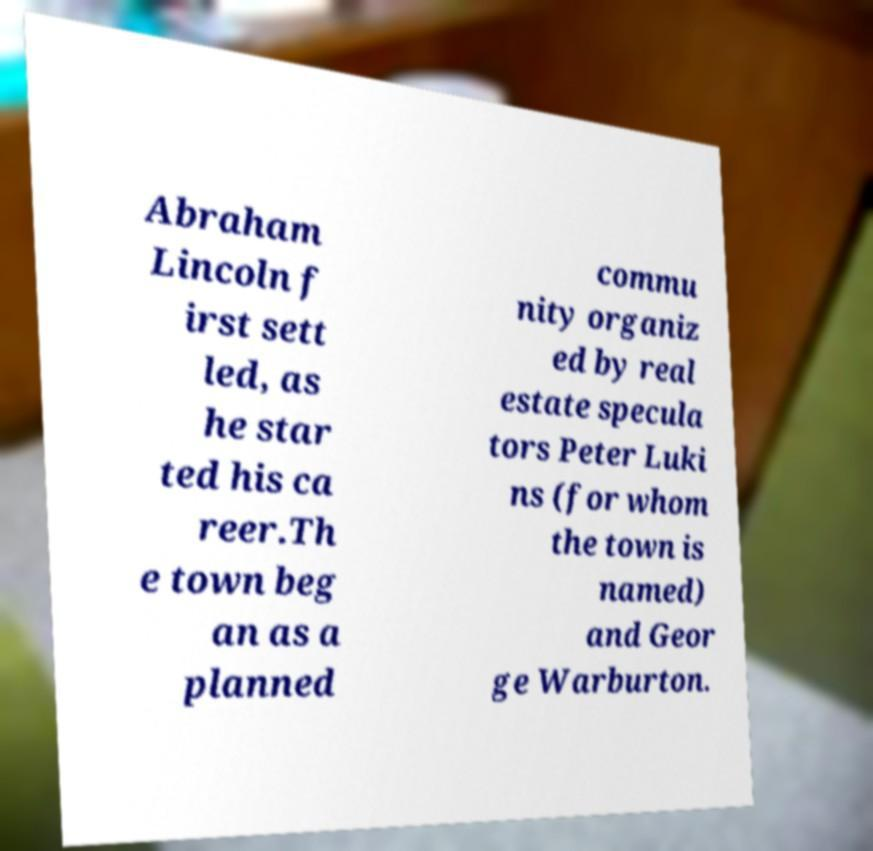I need the written content from this picture converted into text. Can you do that? Abraham Lincoln f irst sett led, as he star ted his ca reer.Th e town beg an as a planned commu nity organiz ed by real estate specula tors Peter Luki ns (for whom the town is named) and Geor ge Warburton. 